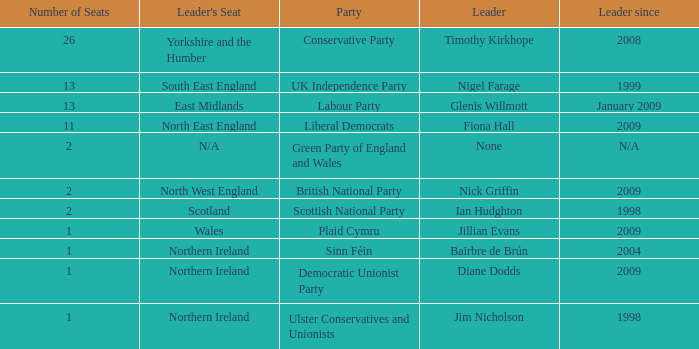What is Jillian Evans highest number of seats? 1.0. 